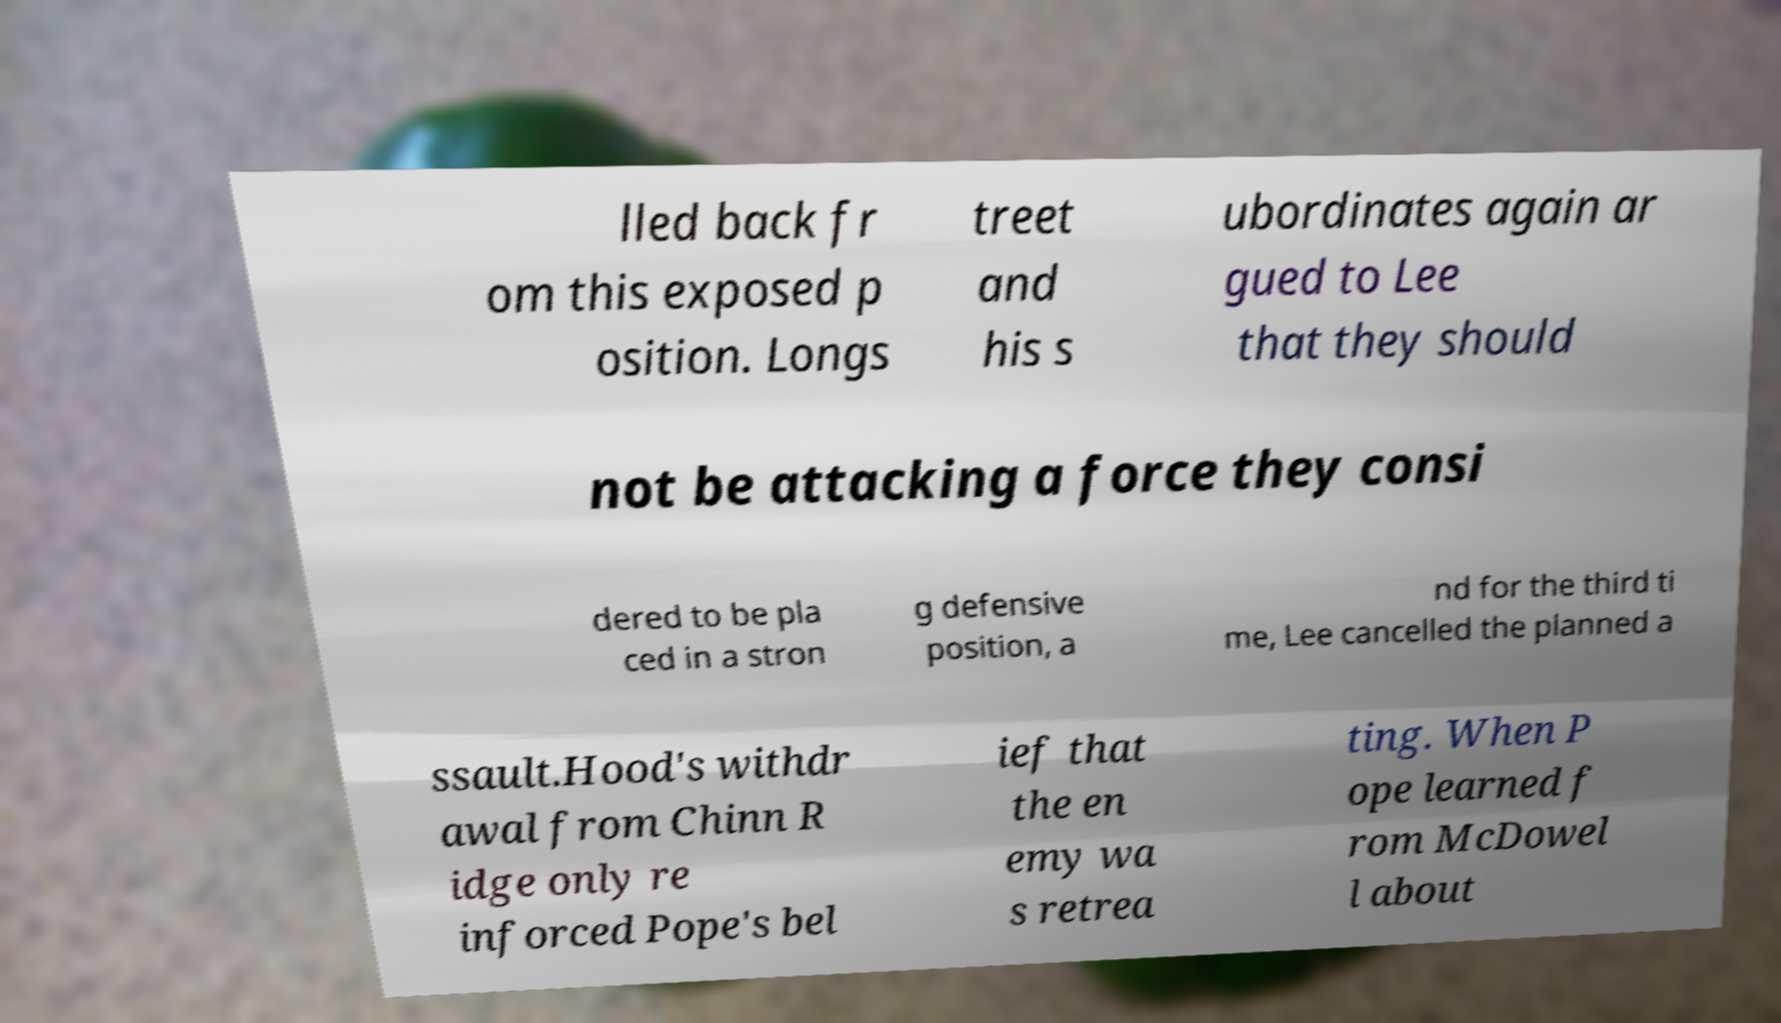Can you read and provide the text displayed in the image?This photo seems to have some interesting text. Can you extract and type it out for me? lled back fr om this exposed p osition. Longs treet and his s ubordinates again ar gued to Lee that they should not be attacking a force they consi dered to be pla ced in a stron g defensive position, a nd for the third ti me, Lee cancelled the planned a ssault.Hood's withdr awal from Chinn R idge only re inforced Pope's bel ief that the en emy wa s retrea ting. When P ope learned f rom McDowel l about 